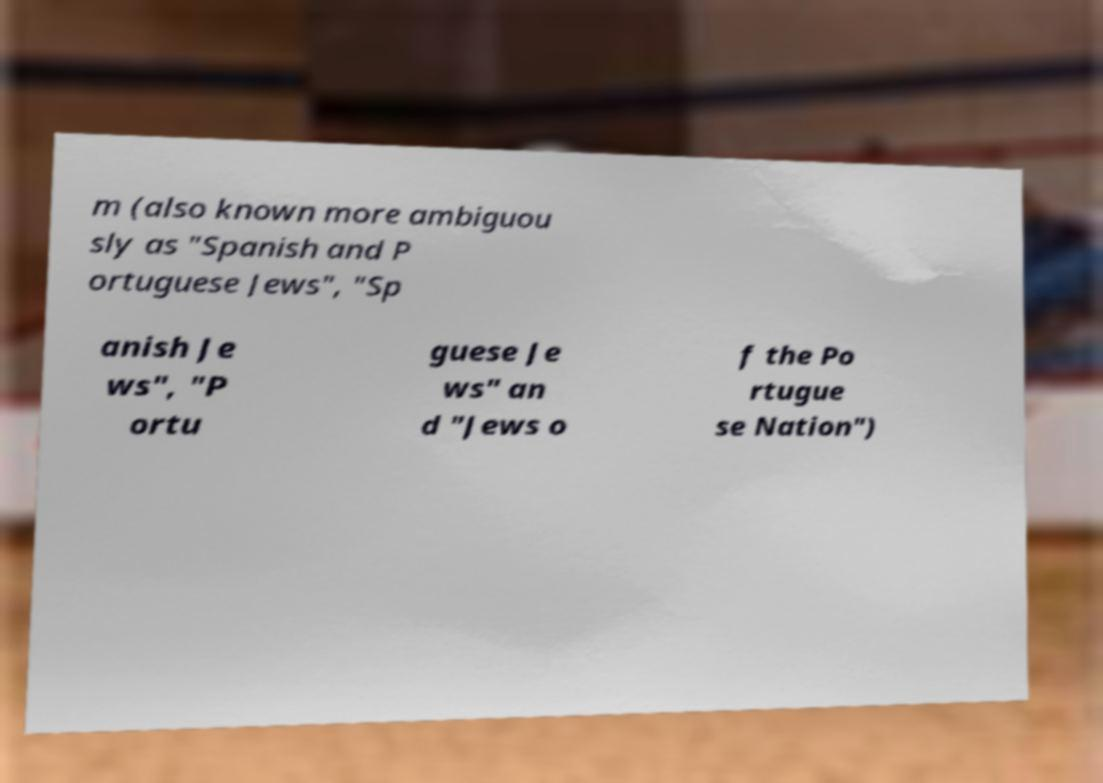I need the written content from this picture converted into text. Can you do that? m (also known more ambiguou sly as "Spanish and P ortuguese Jews", "Sp anish Je ws", "P ortu guese Je ws" an d "Jews o f the Po rtugue se Nation") 